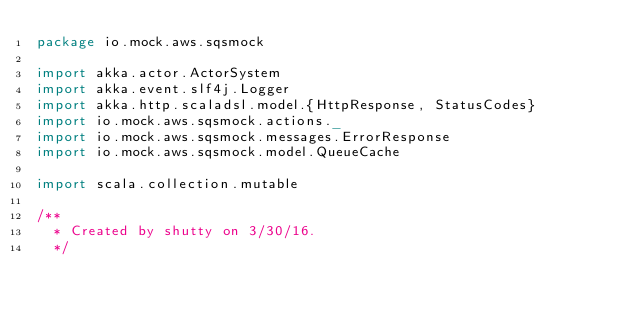Convert code to text. <code><loc_0><loc_0><loc_500><loc_500><_Scala_>package io.mock.aws.sqsmock

import akka.actor.ActorSystem
import akka.event.slf4j.Logger
import akka.http.scaladsl.model.{HttpResponse, StatusCodes}
import io.mock.aws.sqsmock.actions._
import io.mock.aws.sqsmock.messages.ErrorResponse
import io.mock.aws.sqsmock.model.QueueCache

import scala.collection.mutable

/**
  * Created by shutty on 3/30/16.
  */</code> 